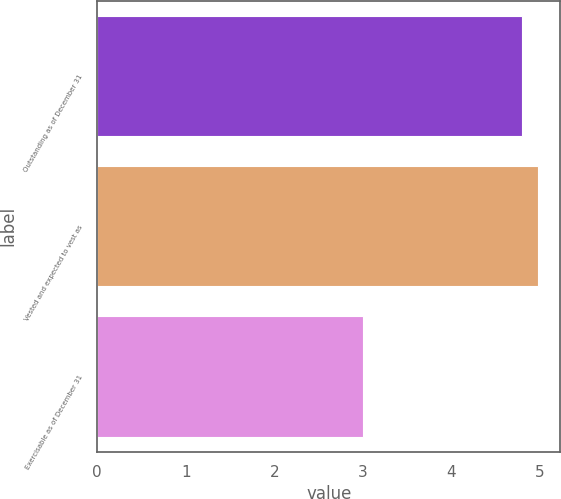Convert chart. <chart><loc_0><loc_0><loc_500><loc_500><bar_chart><fcel>Outstanding as of December 31<fcel>Vested and expected to vest as<fcel>Exercisable as of December 31<nl><fcel>4.8<fcel>4.98<fcel>3<nl></chart> 